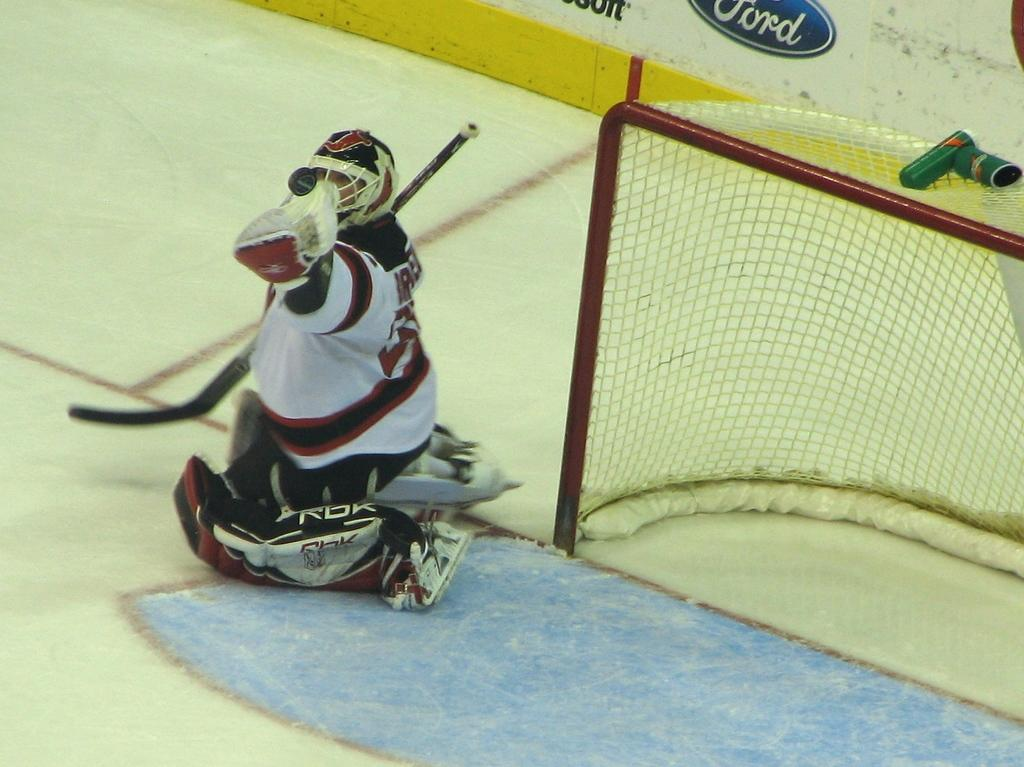What is the person in the image doing? The person is holding a bat in the image. What is the person's position in the image? The person is sitting on the ground. What can be seen on the right side of the image? There is a net on the right side of the image. What is another structure visible in the image? There is a wall in the image. How does the person compare their bat to the moon in the image? There is no moon present in the image, so it is not possible to make a comparison between the bat and the moon. 